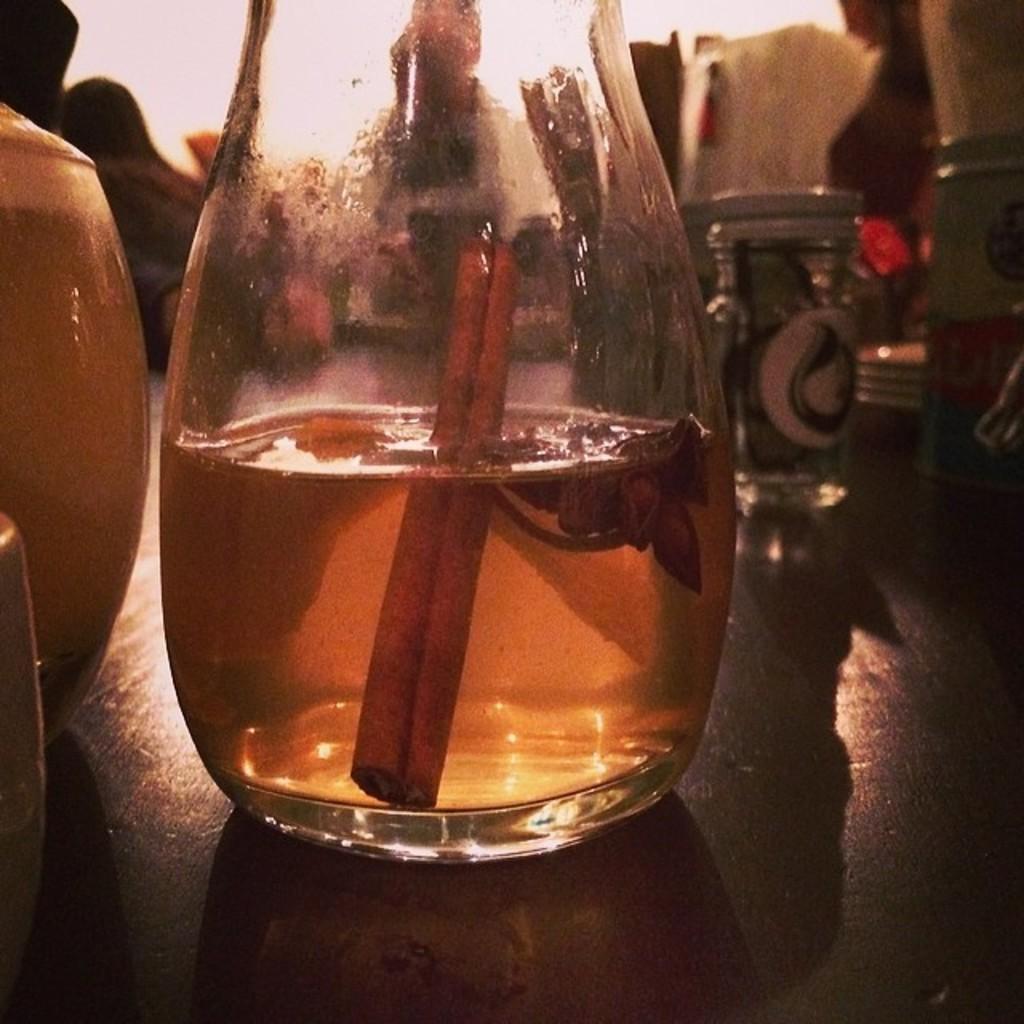Can you describe this image briefly? There is a glass jar some dissolved solution in it. 